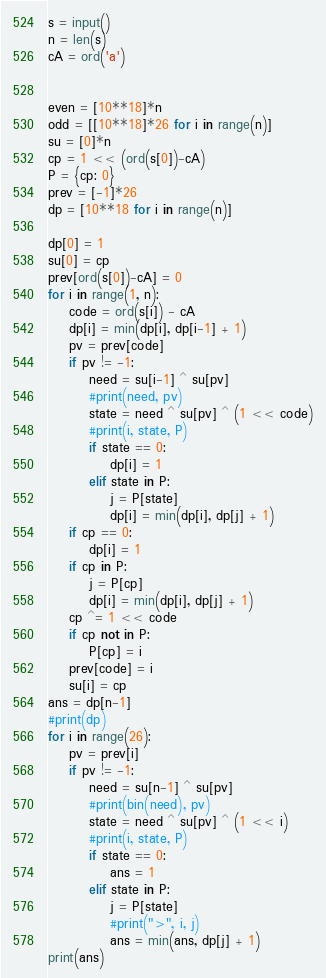<code> <loc_0><loc_0><loc_500><loc_500><_Python_>s = input()
n = len(s)
cA = ord('a')


even = [10**18]*n
odd = [[10**18]*26 for i in range(n)]
su = [0]*n
cp = 1 << (ord(s[0])-cA)
P = {cp: 0}
prev = [-1]*26
dp = [10**18 for i in range(n)]

dp[0] = 1
su[0] = cp
prev[ord(s[0])-cA] = 0
for i in range(1, n):
    code = ord(s[i]) - cA
    dp[i] = min(dp[i], dp[i-1] + 1)
    pv = prev[code]
    if pv != -1:
        need = su[i-1] ^ su[pv]
        #print(need, pv)
        state = need ^ su[pv] ^ (1 << code)
        #print(i, state, P)
        if state == 0:
            dp[i] = 1
        elif state in P:
            j = P[state]
            dp[i] = min(dp[i], dp[j] + 1)
    if cp == 0:
        dp[i] = 1
    if cp in P:
        j = P[cp]
        dp[i] = min(dp[i], dp[j] + 1)
    cp ^= 1 << code
    if cp not in P:
        P[cp] = i
    prev[code] = i
    su[i] = cp
ans = dp[n-1]
#print(dp)
for i in range(26):
    pv = prev[i]
    if pv != -1:
        need = su[n-1] ^ su[pv]
        #print(bin(need), pv)
        state = need ^ su[pv] ^ (1 << i)
        #print(i, state, P)
        if state == 0:
            ans = 1
        elif state in P:
            j = P[state]
            #print(">", i, j)
            ans = min(ans, dp[j] + 1)
print(ans)
</code> 